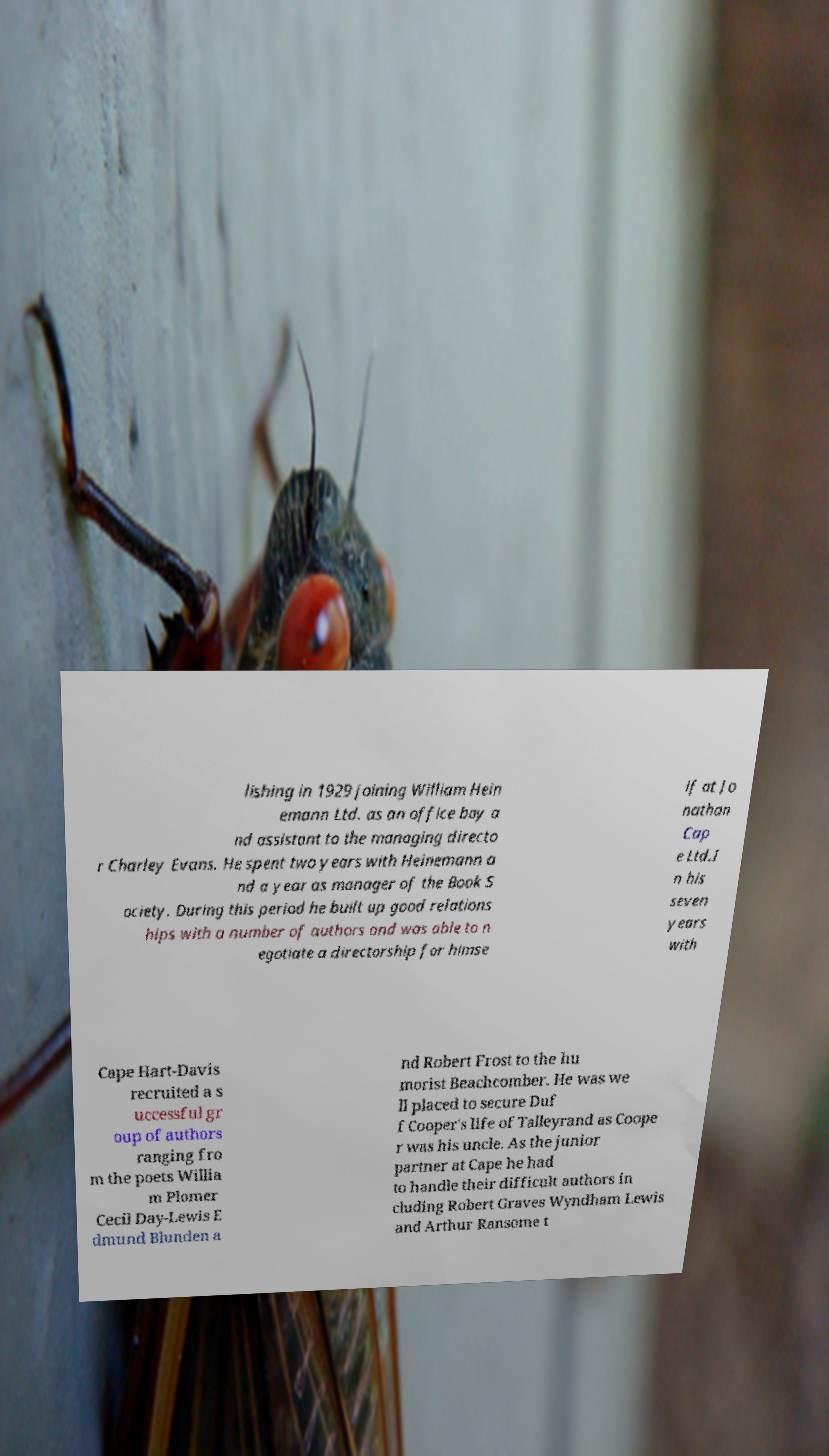What messages or text are displayed in this image? I need them in a readable, typed format. lishing in 1929 joining William Hein emann Ltd. as an office boy a nd assistant to the managing directo r Charley Evans. He spent two years with Heinemann a nd a year as manager of the Book S ociety. During this period he built up good relations hips with a number of authors and was able to n egotiate a directorship for himse lf at Jo nathan Cap e Ltd.I n his seven years with Cape Hart-Davis recruited a s uccessful gr oup of authors ranging fro m the poets Willia m Plomer Cecil Day-Lewis E dmund Blunden a nd Robert Frost to the hu morist Beachcomber. He was we ll placed to secure Duf f Cooper's life of Talleyrand as Coope r was his uncle. As the junior partner at Cape he had to handle their difficult authors in cluding Robert Graves Wyndham Lewis and Arthur Ransome t 